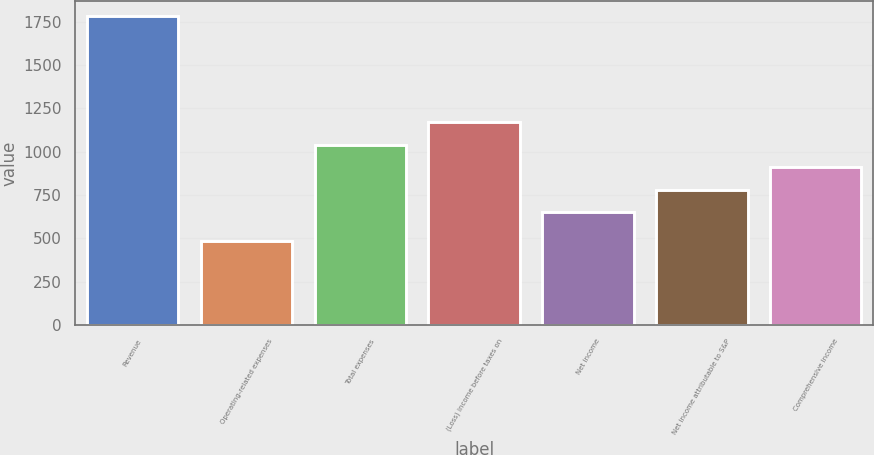<chart> <loc_0><loc_0><loc_500><loc_500><bar_chart><fcel>Revenue<fcel>Operating-related expenses<fcel>Total expenses<fcel>(Loss) income before taxes on<fcel>Net income<fcel>Net income attributable to S&P<fcel>Comprehensive income<nl><fcel>1780<fcel>482<fcel>1038.4<fcel>1168.2<fcel>649<fcel>778.8<fcel>908.6<nl></chart> 